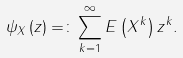Convert formula to latex. <formula><loc_0><loc_0><loc_500><loc_500>\psi _ { X } \left ( z \right ) = \colon \sum _ { k = 1 } ^ { \infty } E \left ( X ^ { k } \right ) z ^ { k } .</formula> 